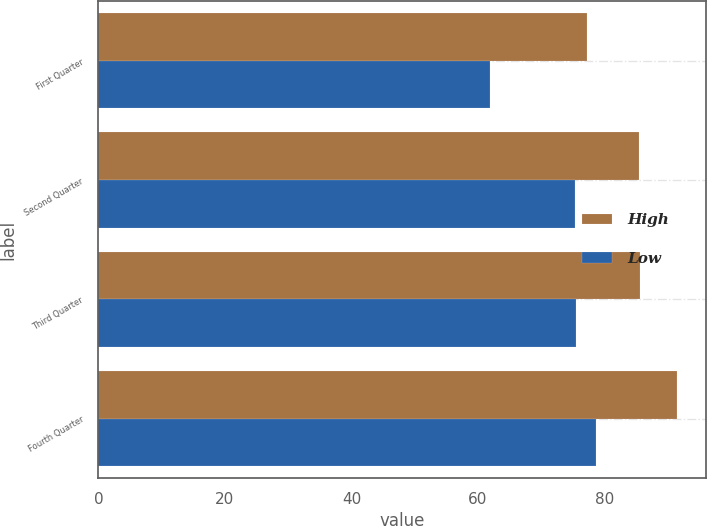Convert chart. <chart><loc_0><loc_0><loc_500><loc_500><stacked_bar_chart><ecel><fcel>First Quarter<fcel>Second Quarter<fcel>Third Quarter<fcel>Fourth Quarter<nl><fcel>High<fcel>77.25<fcel>85.4<fcel>85.56<fcel>91.51<nl><fcel>Low<fcel>61.85<fcel>75.38<fcel>75.58<fcel>78.64<nl></chart> 